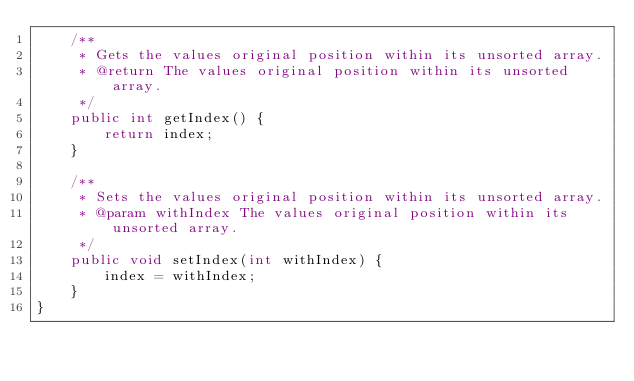<code> <loc_0><loc_0><loc_500><loc_500><_Java_>    /**
     * Gets the values original position within its unsorted array.
     * @return The values original position within its unsorted array.
     */
    public int getIndex() {
        return index;
    }

    /**
     * Sets the values original position within its unsorted array.
     * @param withIndex The values original position within its unsorted array.
     */
    public void setIndex(int withIndex) {
        index = withIndex;
    }
}
</code> 